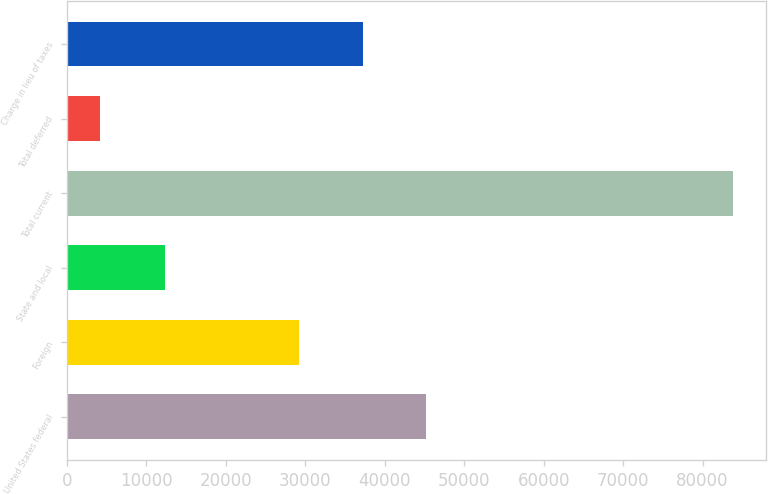Convert chart. <chart><loc_0><loc_0><loc_500><loc_500><bar_chart><fcel>United States federal<fcel>Foreign<fcel>State and local<fcel>Total current<fcel>Total deferred<fcel>Charge in lieu of taxes<nl><fcel>45189.2<fcel>29260<fcel>12320<fcel>83818<fcel>4172<fcel>37224.6<nl></chart> 